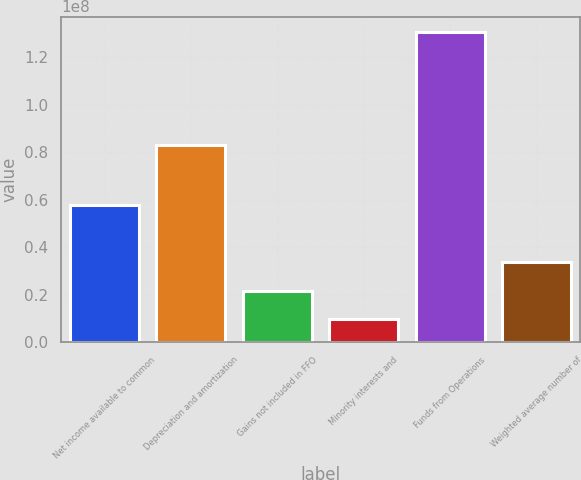Convert chart. <chart><loc_0><loc_0><loc_500><loc_500><bar_chart><fcel>Net income available to common<fcel>Depreciation and amortization<fcel>Gains not included in FFO<fcel>Minority interests and<fcel>Funds from Operations<fcel>Weighted average number of<nl><fcel>5.7603e+07<fcel>8.3034e+07<fcel>2.16441e+07<fcel>9.547e+06<fcel>1.30518e+08<fcel>3.37412e+07<nl></chart> 